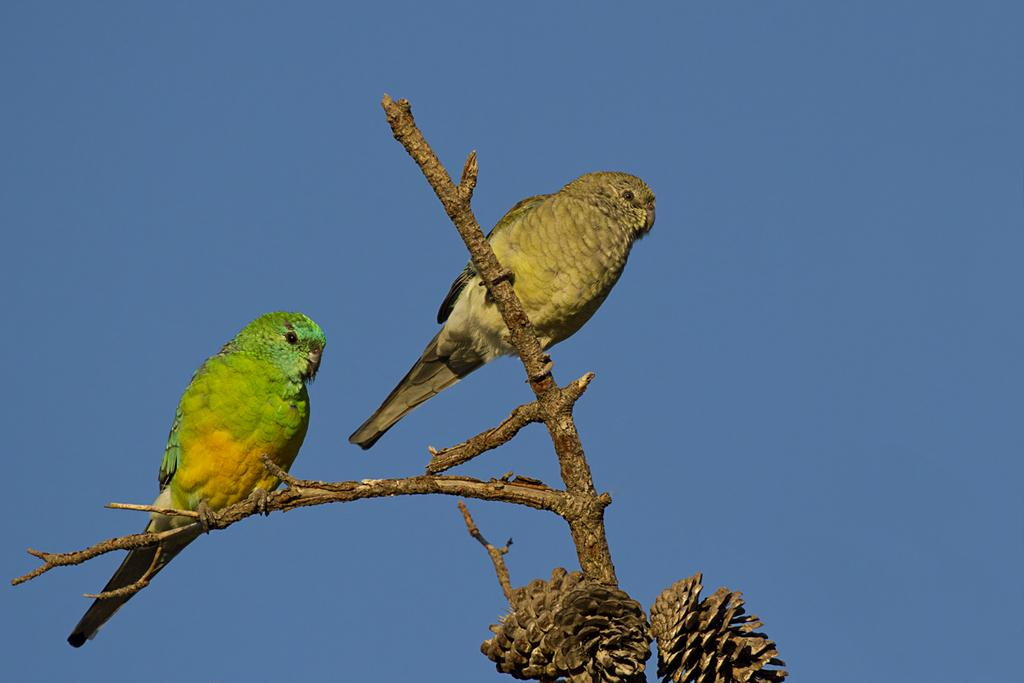How many birds are in the image? There are two birds in the image. Where are the birds located? The birds are on a branch. What can be seen in the background of the image? The background of the image includes a blue sky. What type of beetle can be seen crawling on the branch with the birds? There is no beetle present in the image; only the two birds are visible on the branch. 